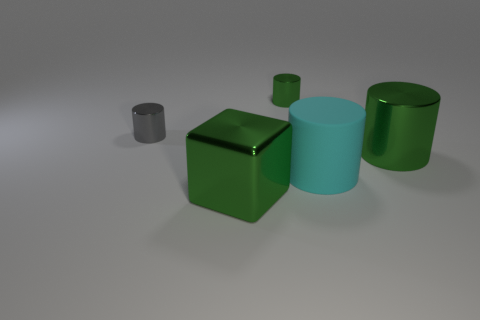Subtract all red cylinders. Subtract all yellow blocks. How many cylinders are left? 4 Add 3 tiny brown rubber objects. How many objects exist? 8 Subtract all cubes. How many objects are left? 4 Add 3 tiny gray shiny objects. How many tiny gray shiny objects are left? 4 Add 3 big blocks. How many big blocks exist? 4 Subtract 0 yellow cylinders. How many objects are left? 5 Subtract all tiny gray metal things. Subtract all green metallic things. How many objects are left? 1 